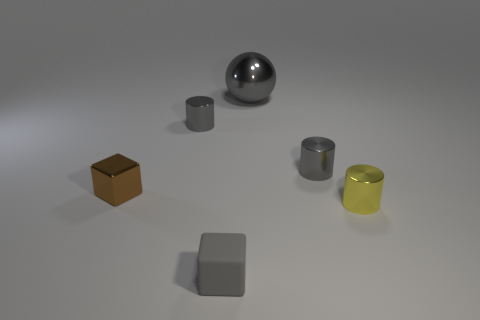Is there anything else that has the same material as the gray block?
Your answer should be compact. No. Is the small rubber thing the same color as the large thing?
Provide a succinct answer. Yes. Do the sphere and the tiny brown block have the same material?
Provide a short and direct response. Yes. What is the size of the ball that is the same color as the small matte cube?
Your answer should be compact. Large. Are there any large gray spheres that have the same material as the yellow object?
Provide a succinct answer. Yes. There is a cylinder that is to the left of the gray metallic cylinder that is right of the big thing that is on the left side of the yellow thing; what color is it?
Your response must be concise. Gray. What number of red objects are either tiny shiny things or small matte cubes?
Ensure brevity in your answer.  0. What number of other yellow objects have the same shape as the yellow shiny object?
Your response must be concise. 0. There is a gray matte thing that is the same size as the brown cube; what is its shape?
Give a very brief answer. Cube. Are there any tiny yellow metal cylinders left of the rubber cube?
Offer a terse response. No. 